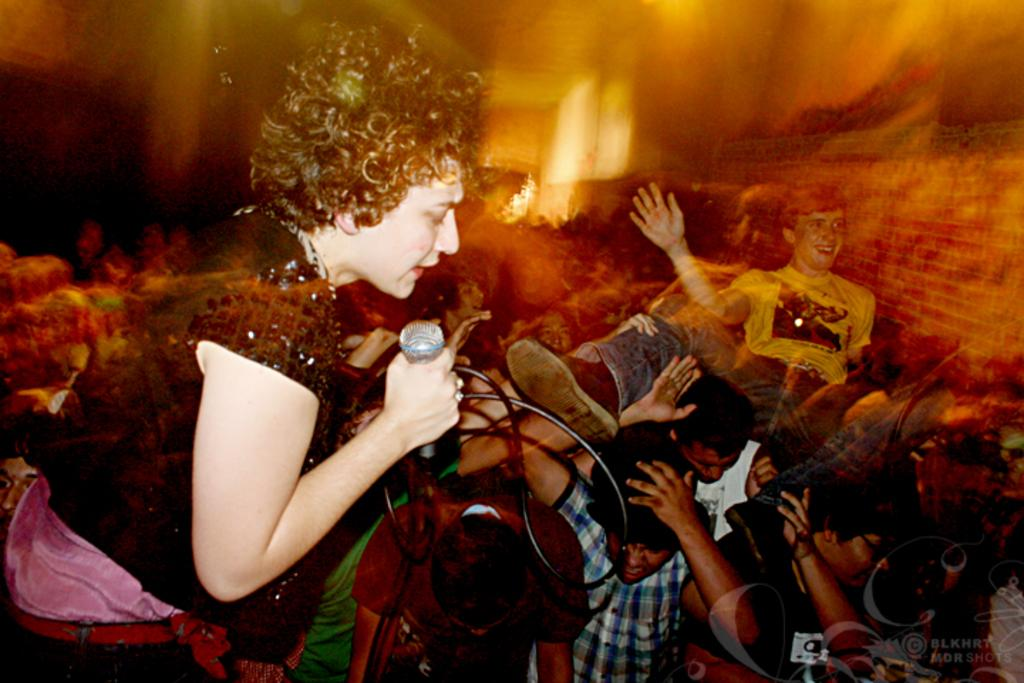What can be seen in the image? There are kids standing in the image, along with a woman. Can you describe the woman's appearance? The woman is wearing a black dress. What is the woman holding in her hands? The woman is holding a microphone in her hands. How would you describe the background of the image? The background of the image is blurry. What type of camp can be seen in the background of the image? There is no camp visible in the background of the image; it is blurry. What sense is being exchanged between the kids and the woman in the image? There is no exchange of senses depicted in the image; it shows kids standing and a woman holding a microphone. 